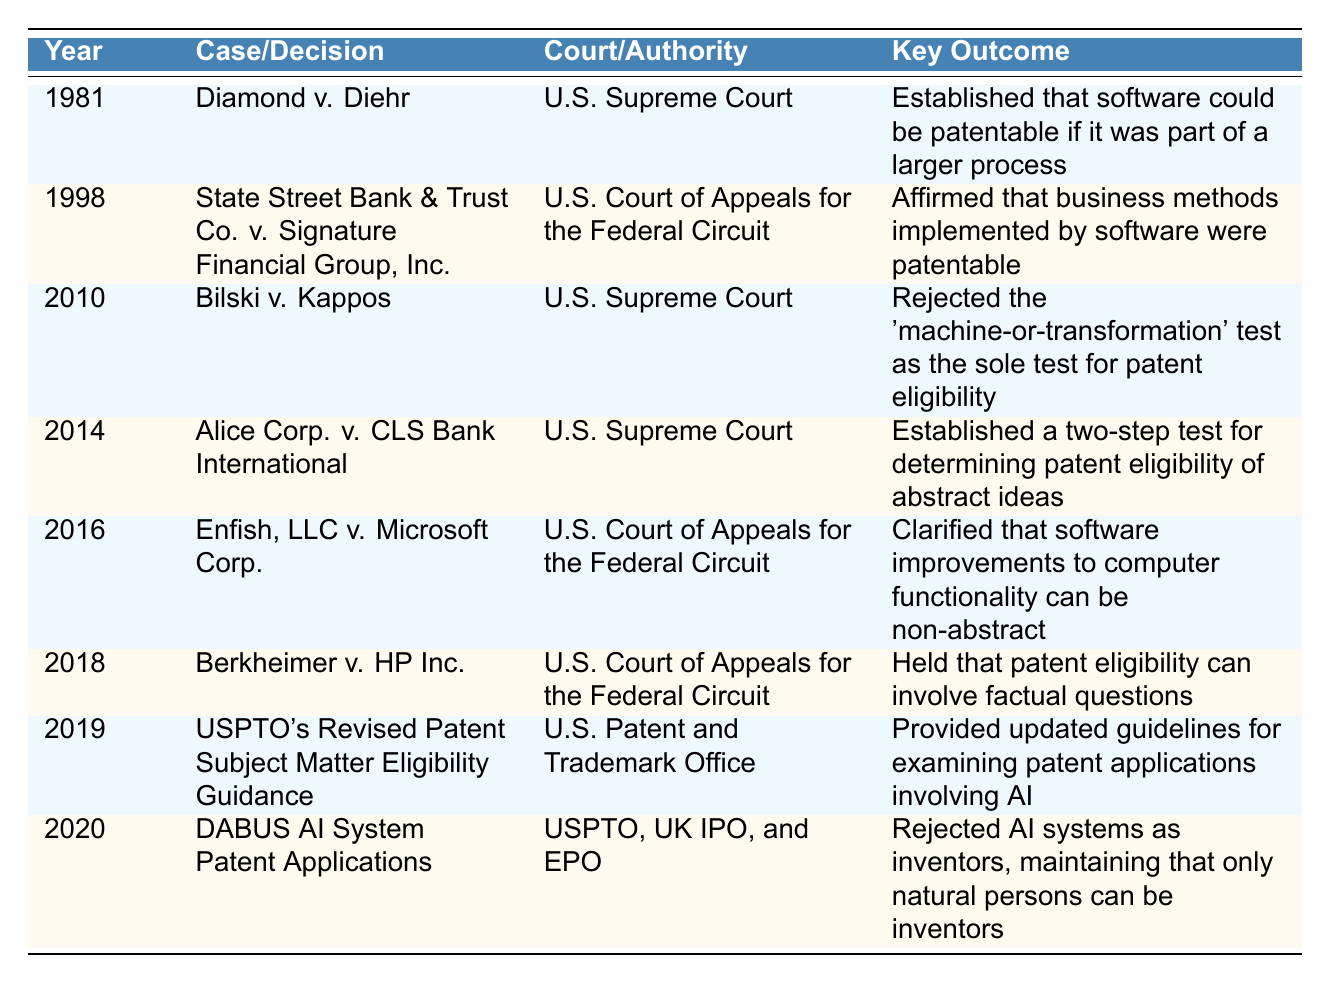What year was the case "Diamond v. Diehr" decided? The table indicates that "Diamond v. Diehr" was decided in the year 1981.
Answer: 1981 Which court decided the case "Alice Corp. v. CLS Bank International"? The table shows that "Alice Corp. v. CLS Bank International" was decided by the U.S. Supreme Court.
Answer: U.S. Supreme Court What is the key outcome of the "Bilski v. Kappos" decision? According to the table, the key outcome of "Bilski v. Kappos" is the rejection of the 'machine-or-transformation' test as the sole test for patent eligibility.
Answer: Rejected the 'machine-or-transformation' test as the sole test for patent eligibility In what year did the U.S. Patent and Trademark Office provide revised guidelines for patent eligibility involving AI? The table indicates that the revised guidelines were provided in 2019.
Answer: 2019 How many decisions were issued by the U.S. Supreme Court in this timeline? By reviewing the table, we see that there are four cases listed under the U.S. Supreme Court: "Diamond v. Diehr," "Bilski v. Kappos," "Alice Corp. v. CLS Bank International," and "DABUS AI System Patent Applications," which totals to four.
Answer: 4 Was the "State Street Bank & Trust Co. v. Signature Financial Group, Inc." decision favorable for the patentability of business methods? Yes, the key outcome listed states that it affirmed business methods implemented by software as patentable technology.
Answer: Yes Which case clarified that software improvements to computer functionality can be non-abstract? The case "Enfish, LLC v. Microsoft Corp." clarified that software improvements can be non-abstract, as cited in the table.
Answer: Enfish, LLC v. Microsoft Corp Compare the outcomes of "Berkheimer v. HP Inc." and "DABUS AI System Patent Applications" in terms of patent eligibility. "Berkheimer v. HP Inc." held that patent eligibility can involve factual questions, while "DABUS AI System Patent Applications" rejected AI systems as inventors, maintaining that only natural persons can be inventors. This shows differing approaches where one case addresses the role of factual circumstances, and the other focuses on the definition of inventorship.
Answer: Different approaches: factual questions vs. natural persons as inventors What was the key outcome of the "Alice Corp. v. CLS Bank International" case? The table provides that the key outcome was the establishment of a two-step test for determining patent eligibility of abstract ideas.
Answer: Established a two-step test for determining patent eligibility of abstract ideas Identify the time span between the earliest and latest cases listed in the table. The earliest case is from 1981 ("Diamond v. Diehr") and the latest case is from 2020 ("DABUS AI System Patent Applications"). Thus, the time span is 2020 - 1981 = 39 years.
Answer: 39 years 